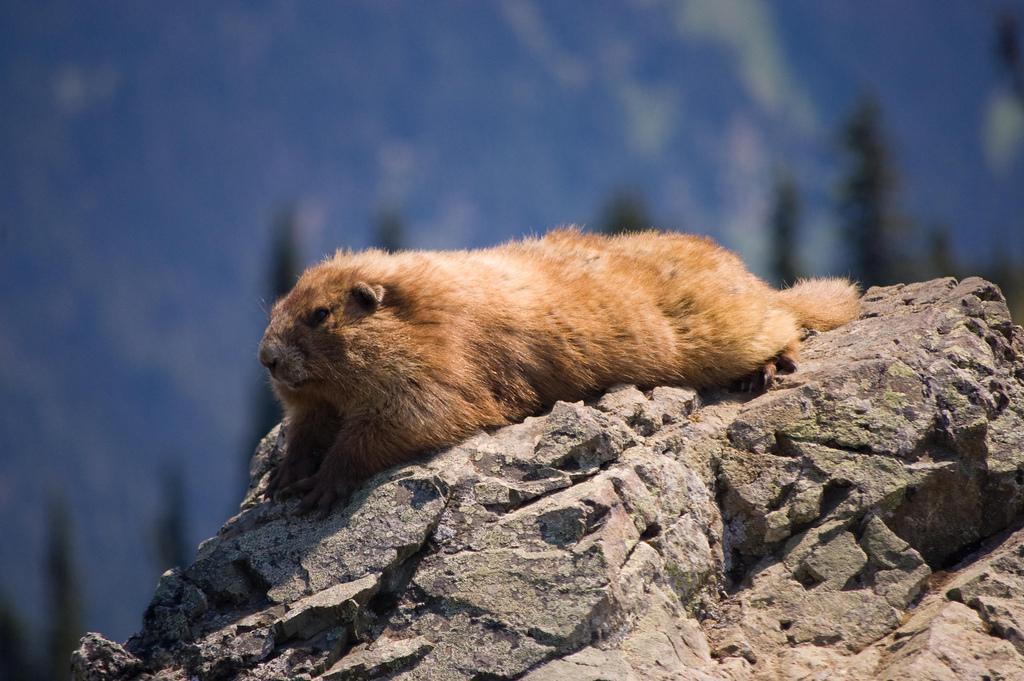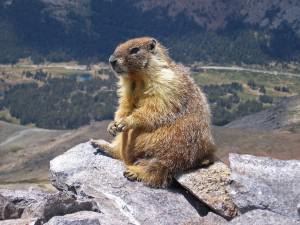The first image is the image on the left, the second image is the image on the right. Evaluate the accuracy of this statement regarding the images: "Two animals are playing with each other in the image on the right.". Is it true? Answer yes or no. No. 